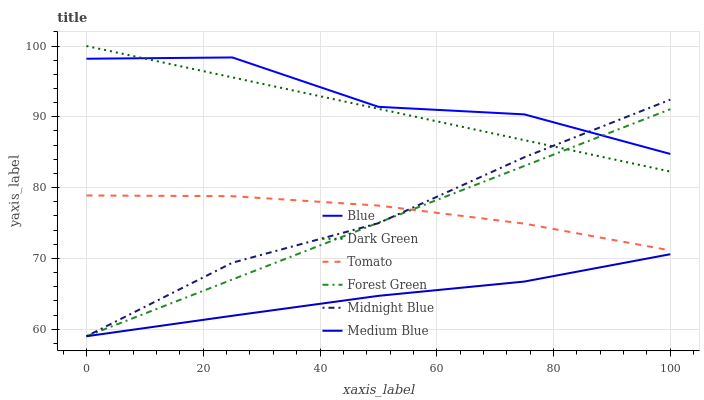Does Tomato have the minimum area under the curve?
Answer yes or no. No. Does Tomato have the maximum area under the curve?
Answer yes or no. No. Is Tomato the smoothest?
Answer yes or no. No. Is Tomato the roughest?
Answer yes or no. No. Does Tomato have the lowest value?
Answer yes or no. No. Does Tomato have the highest value?
Answer yes or no. No. Is Medium Blue less than Dark Green?
Answer yes or no. Yes. Is Blue greater than Medium Blue?
Answer yes or no. Yes. Does Medium Blue intersect Dark Green?
Answer yes or no. No. 